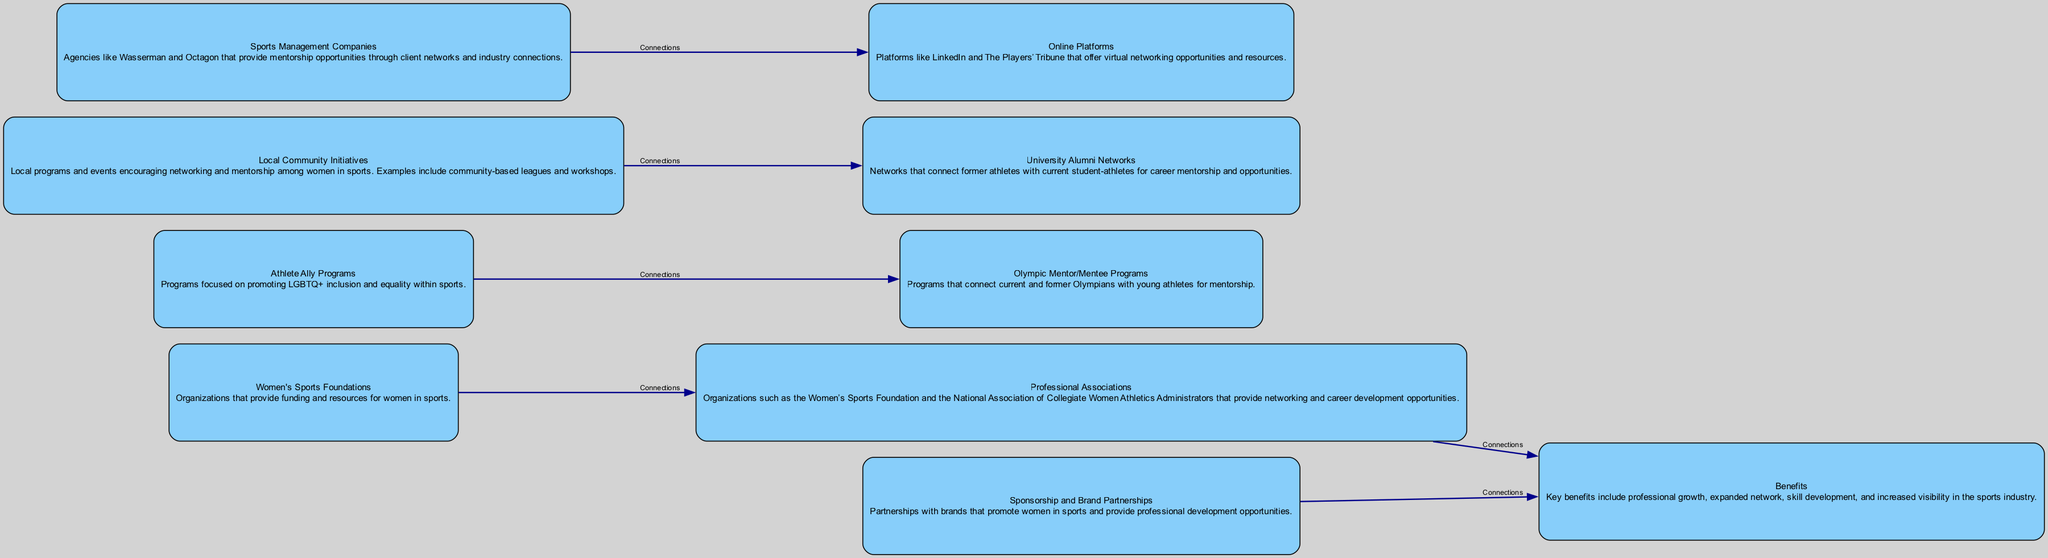What is the total number of nodes in the diagram? The diagram has a total of 10 nodes. This can be determined by counting the "node" elements in the provided data structure, which specifically include the Women's Sports Foundations, Athlete Ally Programs, Professional Associations, Olympic Mentor/Mentee Programs, Local Community Initiatives, University Alumni Networks, Sports Management Companies, Online Platforms, Sponsorship and Brand Partnerships, and Benefits.
Answer: 10 Which program connects to the Professional Associations? The connection source to Professional Associations in the diagram comes from Women's Sports Foundations. Analyzing the connection elements in the data set indicates that there is a direct edge listed between these two nodes, indicating a relationship or flow from Women’s Sports Foundations to Professional Associations.
Answer: Women's Sports Foundations What benefits are linked to Sponsorship and Brand Partnerships? The diagram indicates that Sponsorship and Brand Partnerships connect to Benefits. This is shown in the connections section of the data, which highlights that these two elements have a direct relationship, leading to the category of benefits.
Answer: Benefits How many edges are connecting the nodes in the diagram? There are 6 edges in the diagram that indicate connections between different programs. This is identified by counting the "edge" elements in the provided data, which describe the specific relationships between nodes like Women's Sports Foundations to Professional Associations, among others.
Answer: 6 Which program is associated with promoting LGBTQ+ inclusion? The program promoting LGBTQ+ inclusion is identified as the Athlete Ally Programs. This can be confirmed by referring to the specific node description given in the data, which describes its focus on inclusion and equality within the sports realm.
Answer: Athlete Ally Programs What type of networks are created by the University Alumni Networks? The University Alumni Networks create career mentorship opportunities. By evaluating the node description for University Alumni Networks, we see that its primary role is to connect former athletes with current student-athletes for this purpose.
Answer: Career mentorship opportunities Which program provides mentorship opportunities through industry connections? Sports Management Companies provide mentorship opportunities through industry connections. The data outlines that these agencies connect individuals to wider networks in the sports field, thereby creating avenues for mentorship.
Answer: Sports Management Companies Which community-based initiatives connect to University Alumni Networks? Local Community Initiatives connect to University Alumni Networks. This relationship is specified in the connections section of the dataset indicating that local programs encourage networking and mentorship, leading toward university networks.
Answer: Local Community Initiatives 